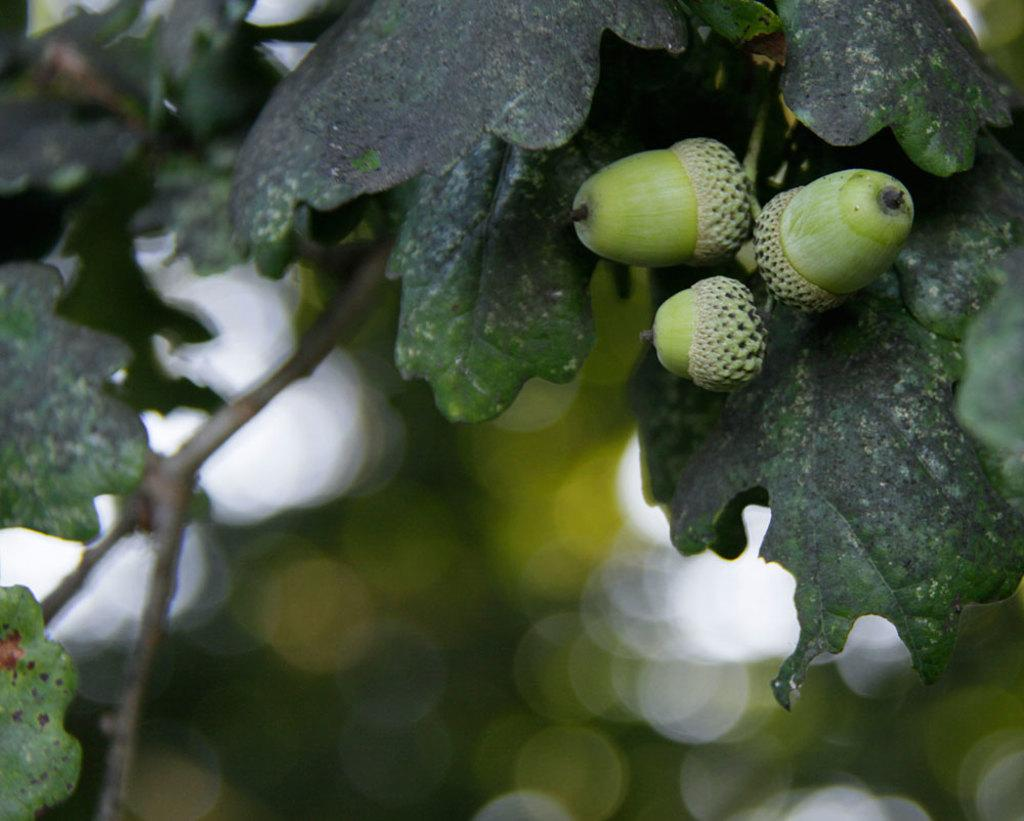What is the main subject of the image? The main subject of the image is a tree. What can be observed about the tree's appearance? The tree has green leaves and fruits. How would you describe the background of the image? The background of the image is blurred. What type of dirt can be seen on the leaves of the tree in the image? There is no dirt visible on the leaves of the tree in the image. Is there a notebook present in the image? There is no notebook present in the image. 